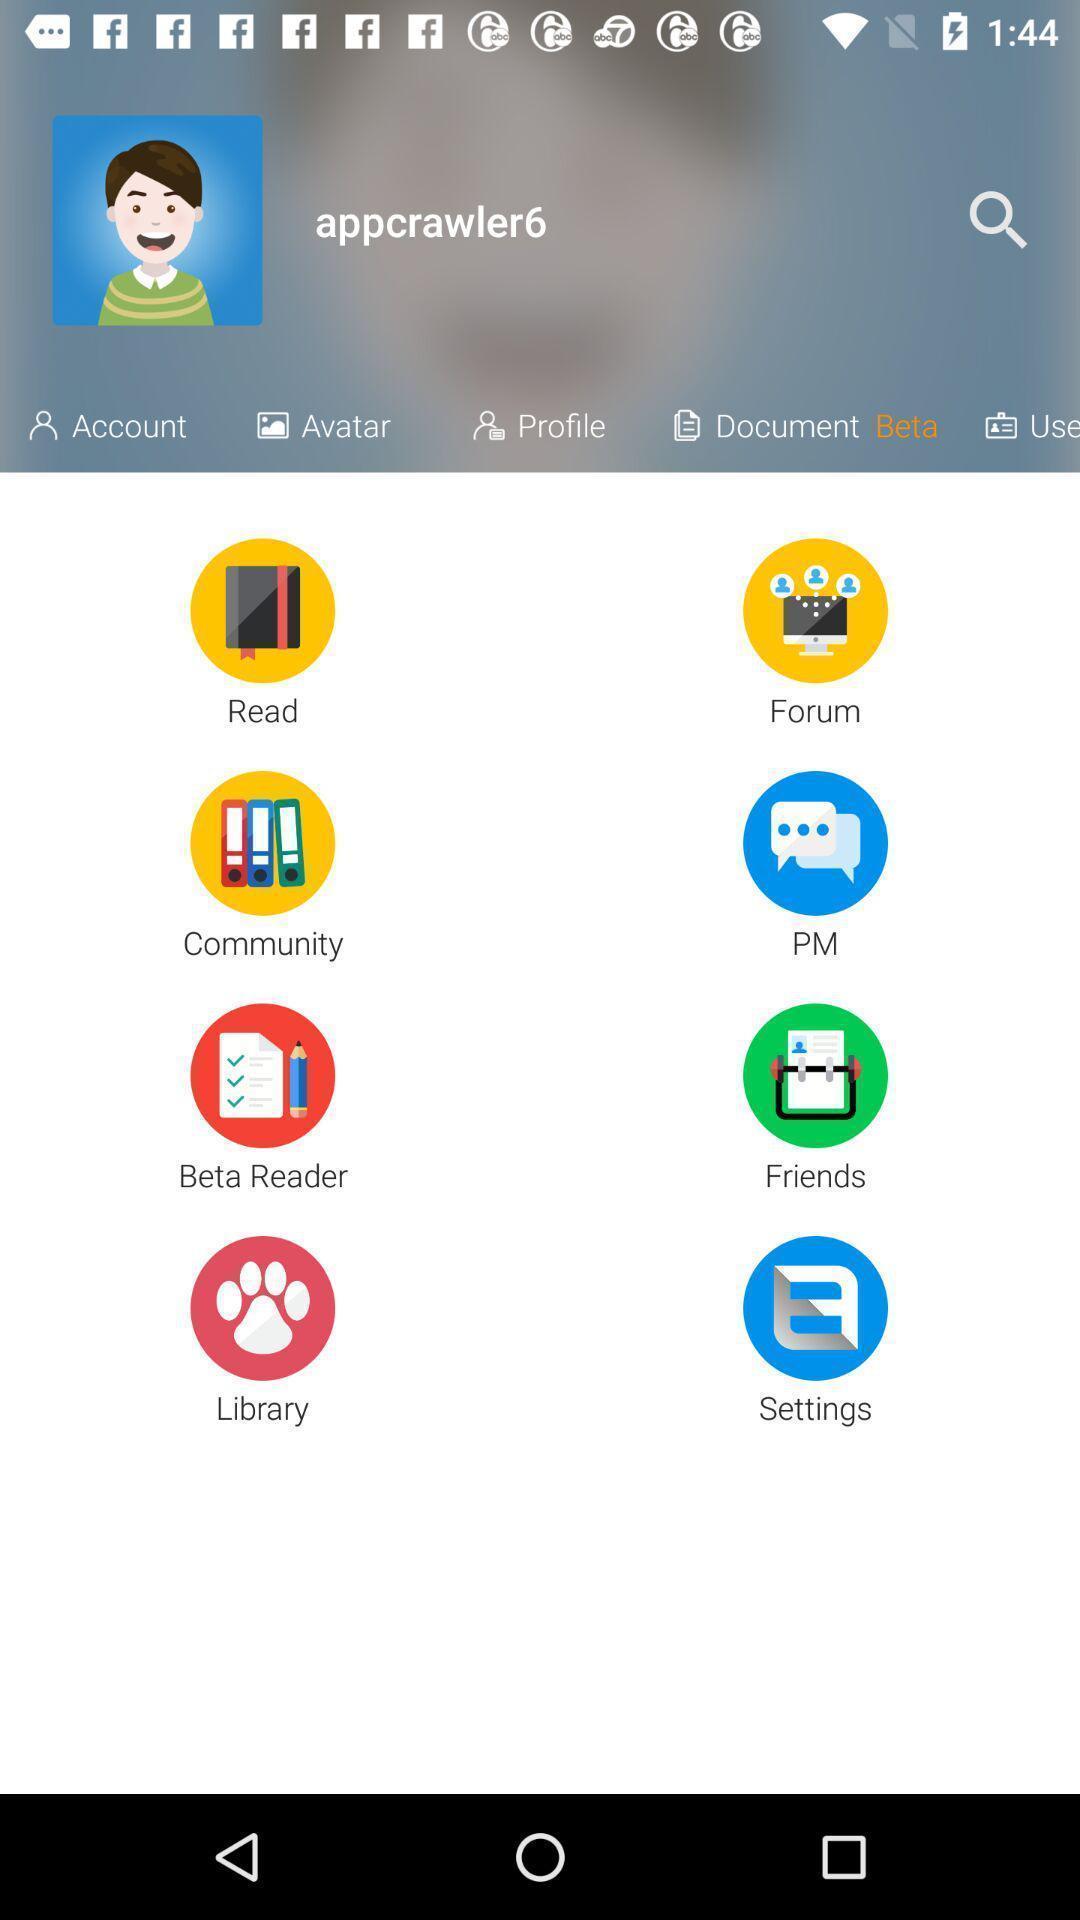Provide a description of this screenshot. Various options displayed of a reading app. 